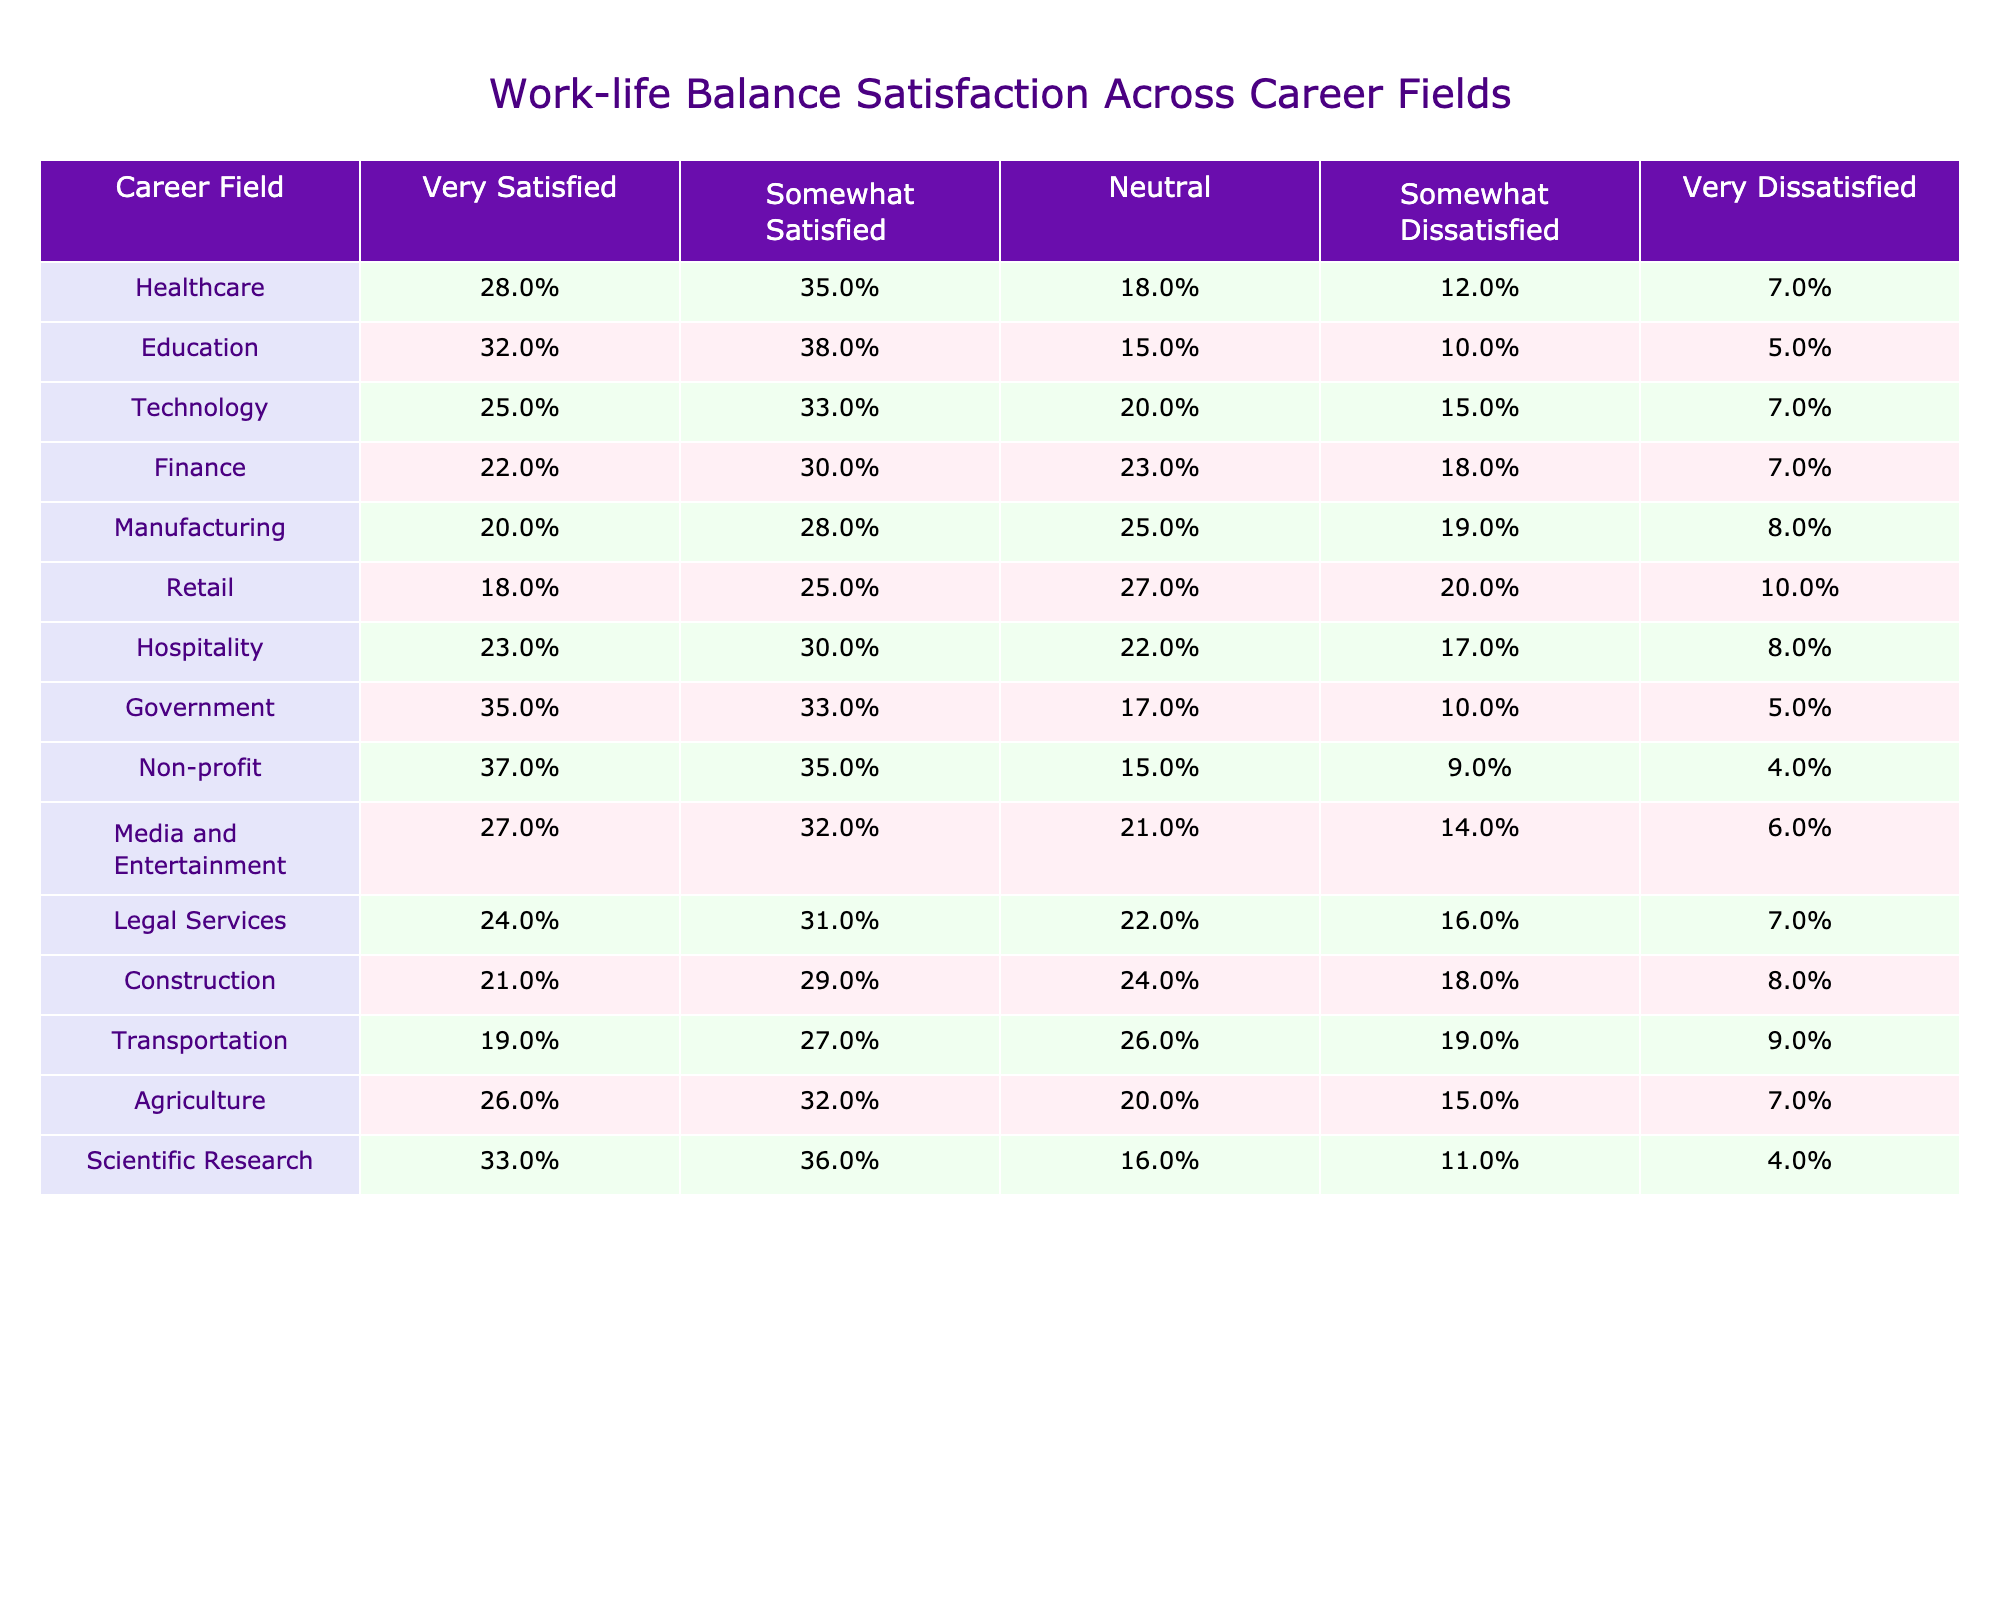What percentage of individuals in the Non-profit field are either very satisfied or somewhat satisfied with their work-life balance? To find this, we sum the percentages of those who are "Very Satisfied" (37%) and "Somewhat Satisfied" (35%) in the Non-profit field. Therefore, the total is 37% + 35% = 72%.
Answer: 72% Which career field has the highest percentage of individuals reporting being very dissatisfied? Looking at the "Very Dissatisfied" column, we see that the Retail field has 10%, which is the highest compared to other fields.
Answer: Retail Is the average percentage of individuals who are "Neutral" in the Manufacturing and Transportation fields greater than 25%? The Neutral percentages are 25% for Manufacturing and 26% for Transportation. The average is (25% + 26%) / 2 = 25.5%. Thus, it is greater than 25%.
Answer: Yes How does the satisfaction rating of very satisfied individuals in Government compare to that in Healthcare? The percentage of very satisfied individuals in Government is 35%, while in Healthcare it is 28%. Since 35% is greater than 28%, Government has a higher rating.
Answer: Government has a higher rating What is the difference in the percentage of individuals who are "Somewhat Dissatisfied" between the Finance and Legal Services fields? From the data, Finance has 18% and Legal Services has 16% in the "Somewhat Dissatisfied" column. The difference is 18% - 16% = 2%.
Answer: 2% Which two career fields, when combined, have the highest percentage of individuals reporting they are very satisfied? The two fields with the highest very satisfied percentages are Non-profit (37%) and Government (35%). Combined, they yield 37% + 35% = 72%.
Answer: Non-profit and Government Is it true that the satisfaction level of the Education field is higher than that of the Transportation field? In the Education field, 32% are very satisfied and 38% are somewhat satisfied, while in Transportation, only 19% are very satisfied and 27% are somewhat satisfied. Thus, Education (70%) is higher than Transportation (46%).
Answer: Yes What is the total percentage of individuals who are satisfied (very satisfied + somewhat satisfied) in the Technology field? For Technology, very satisfied is 25% and somewhat satisfied is 33%. The total is 25% + 33% = 58%.
Answer: 58% Which career field has the lowest percentage of individuals reporting being "Somewhat Satisfied"? By examining the "Somewhat Satisfied" column, Retail shows the lowest at 25%.
Answer: Retail What is the combined percentage of "Very Satisfied" and "Very Dissatisfied" individuals in the Media and Entertainment field? For Media and Entertainment, "Very Satisfied" is 27% and "Very Dissatisfied" is 6%. The combined percentage is 27% + 6% = 33%.
Answer: 33% 